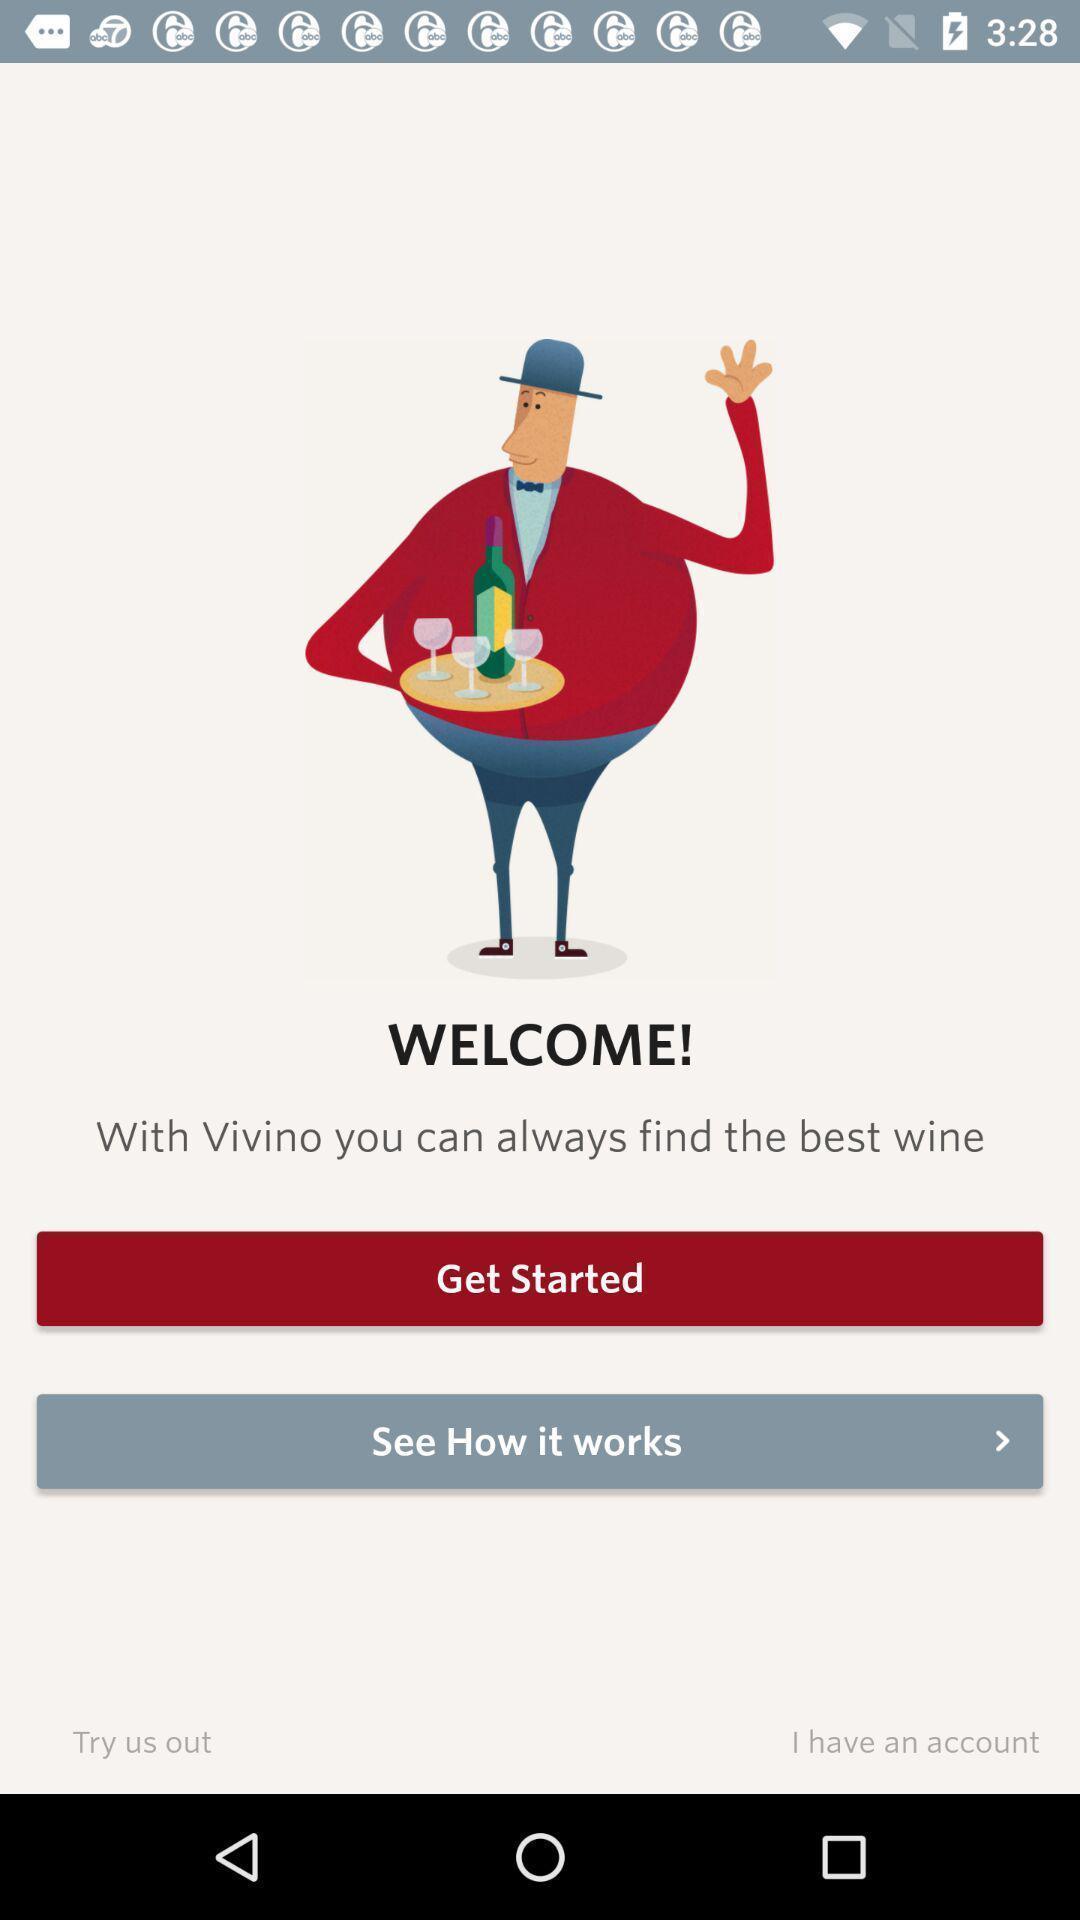Describe the visual elements of this screenshot. Welcome page. 